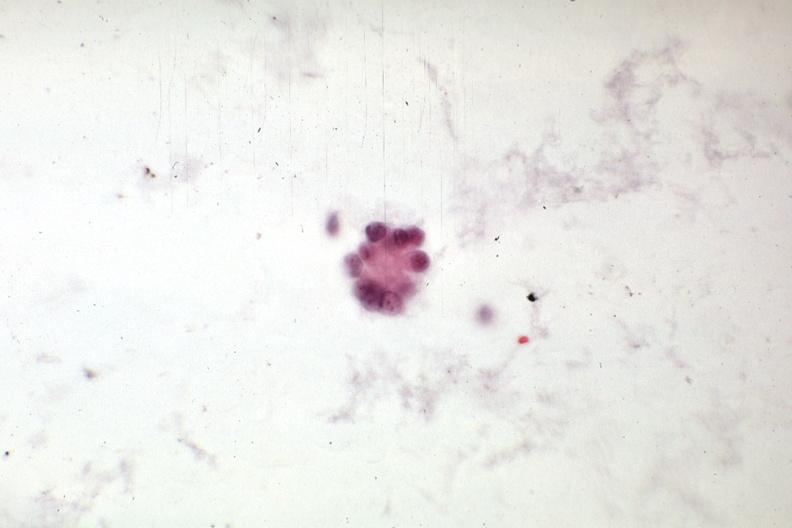does pus in test tube show adenocarcinoma from mixed mesodermal uterine tumor?
Answer the question using a single word or phrase. No 